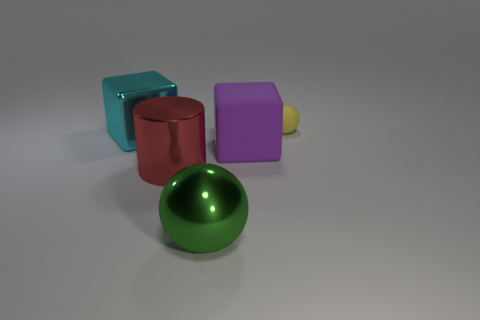Subtract all yellow balls. How many balls are left? 1 Add 2 small red cubes. How many objects exist? 7 Subtract all blocks. How many objects are left? 3 Subtract all cyan blocks. How many green cylinders are left? 0 Subtract all big red things. Subtract all yellow shiny cylinders. How many objects are left? 4 Add 4 green metal objects. How many green metal objects are left? 5 Add 1 big cyan metal cylinders. How many big cyan metal cylinders exist? 1 Subtract 1 green balls. How many objects are left? 4 Subtract 1 balls. How many balls are left? 1 Subtract all green cylinders. Subtract all blue cubes. How many cylinders are left? 1 